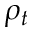<formula> <loc_0><loc_0><loc_500><loc_500>\rho _ { t }</formula> 